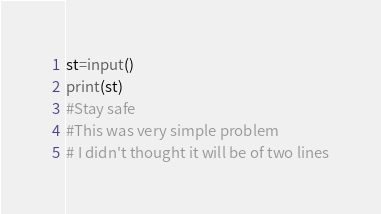<code> <loc_0><loc_0><loc_500><loc_500><_Python_>st=input()
print(st)
#Stay safe
#This was very simple problem
# I didn't thought it will be of two lines
</code> 